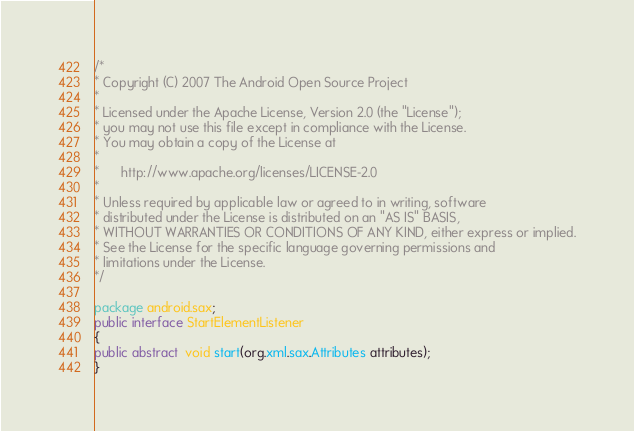<code> <loc_0><loc_0><loc_500><loc_500><_Java_>/*
* Copyright (C) 2007 The Android Open Source Project
*
* Licensed under the Apache License, Version 2.0 (the "License");
* you may not use this file except in compliance with the License.
* You may obtain a copy of the License at
*
*      http://www.apache.org/licenses/LICENSE-2.0
*
* Unless required by applicable law or agreed to in writing, software
* distributed under the License is distributed on an "AS IS" BASIS,
* WITHOUT WARRANTIES OR CONDITIONS OF ANY KIND, either express or implied.
* See the License for the specific language governing permissions and
* limitations under the License.
*/

package android.sax;
public interface StartElementListener
{
public abstract  void start(org.xml.sax.Attributes attributes);
}
</code> 